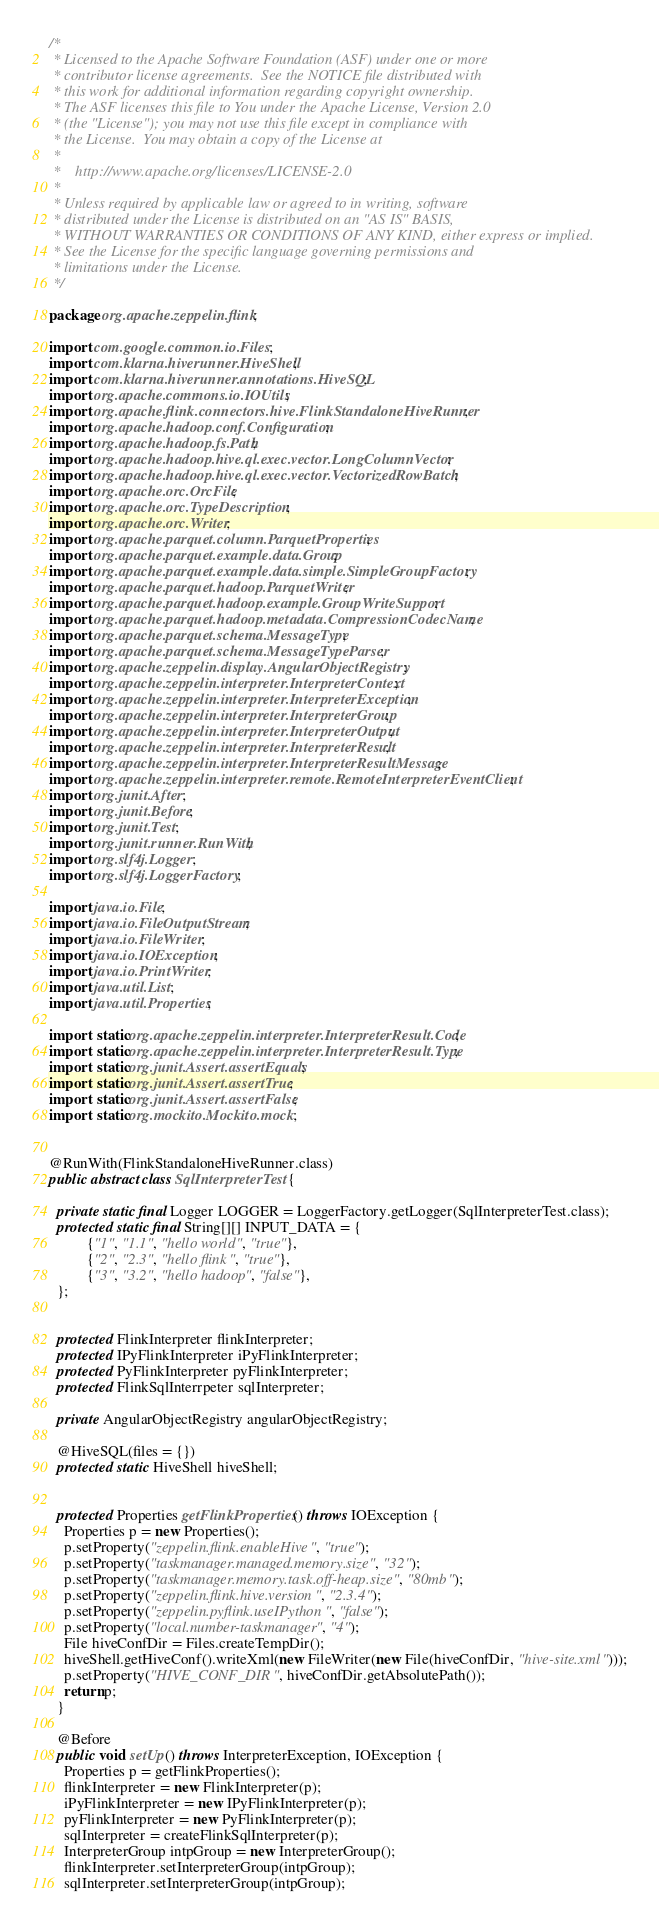<code> <loc_0><loc_0><loc_500><loc_500><_Java_>/*
 * Licensed to the Apache Software Foundation (ASF) under one or more
 * contributor license agreements.  See the NOTICE file distributed with
 * this work for additional information regarding copyright ownership.
 * The ASF licenses this file to You under the Apache License, Version 2.0
 * (the "License"); you may not use this file except in compliance with
 * the License.  You may obtain a copy of the License at
 *
 *    http://www.apache.org/licenses/LICENSE-2.0
 *
 * Unless required by applicable law or agreed to in writing, software
 * distributed under the License is distributed on an "AS IS" BASIS,
 * WITHOUT WARRANTIES OR CONDITIONS OF ANY KIND, either express or implied.
 * See the License for the specific language governing permissions and
 * limitations under the License.
 */

package org.apache.zeppelin.flink;

import com.google.common.io.Files;
import com.klarna.hiverunner.HiveShell;
import com.klarna.hiverunner.annotations.HiveSQL;
import org.apache.commons.io.IOUtils;
import org.apache.flink.connectors.hive.FlinkStandaloneHiveRunner;
import org.apache.hadoop.conf.Configuration;
import org.apache.hadoop.fs.Path;
import org.apache.hadoop.hive.ql.exec.vector.LongColumnVector;
import org.apache.hadoop.hive.ql.exec.vector.VectorizedRowBatch;
import org.apache.orc.OrcFile;
import org.apache.orc.TypeDescription;
import org.apache.orc.Writer;
import org.apache.parquet.column.ParquetProperties;
import org.apache.parquet.example.data.Group;
import org.apache.parquet.example.data.simple.SimpleGroupFactory;
import org.apache.parquet.hadoop.ParquetWriter;
import org.apache.parquet.hadoop.example.GroupWriteSupport;
import org.apache.parquet.hadoop.metadata.CompressionCodecName;
import org.apache.parquet.schema.MessageType;
import org.apache.parquet.schema.MessageTypeParser;
import org.apache.zeppelin.display.AngularObjectRegistry;
import org.apache.zeppelin.interpreter.InterpreterContext;
import org.apache.zeppelin.interpreter.InterpreterException;
import org.apache.zeppelin.interpreter.InterpreterGroup;
import org.apache.zeppelin.interpreter.InterpreterOutput;
import org.apache.zeppelin.interpreter.InterpreterResult;
import org.apache.zeppelin.interpreter.InterpreterResultMessage;
import org.apache.zeppelin.interpreter.remote.RemoteInterpreterEventClient;
import org.junit.After;
import org.junit.Before;
import org.junit.Test;
import org.junit.runner.RunWith;
import org.slf4j.Logger;
import org.slf4j.LoggerFactory;

import java.io.File;
import java.io.FileOutputStream;
import java.io.FileWriter;
import java.io.IOException;
import java.io.PrintWriter;
import java.util.List;
import java.util.Properties;

import static org.apache.zeppelin.interpreter.InterpreterResult.Code;
import static org.apache.zeppelin.interpreter.InterpreterResult.Type;
import static org.junit.Assert.assertEquals;
import static org.junit.Assert.assertTrue;
import static org.junit.Assert.assertFalse;
import static org.mockito.Mockito.mock;


@RunWith(FlinkStandaloneHiveRunner.class)
public abstract class SqlInterpreterTest {

  private static final Logger LOGGER = LoggerFactory.getLogger(SqlInterpreterTest.class);
  protected static final String[][] INPUT_DATA = {
          {"1", "1.1", "hello world", "true"},
          {"2", "2.3", "hello flink", "true"},
          {"3", "3.2", "hello hadoop", "false"},
  };


  protected FlinkInterpreter flinkInterpreter;
  protected IPyFlinkInterpreter iPyFlinkInterpreter;
  protected PyFlinkInterpreter pyFlinkInterpreter;
  protected FlinkSqlInterrpeter sqlInterpreter;

  private AngularObjectRegistry angularObjectRegistry;

  @HiveSQL(files = {})
  protected static HiveShell hiveShell;


  protected Properties getFlinkProperties() throws IOException {
    Properties p = new Properties();
    p.setProperty("zeppelin.flink.enableHive", "true");
    p.setProperty("taskmanager.managed.memory.size", "32");
    p.setProperty("taskmanager.memory.task.off-heap.size", "80mb");
    p.setProperty("zeppelin.flink.hive.version", "2.3.4");
    p.setProperty("zeppelin.pyflink.useIPython", "false");
    p.setProperty("local.number-taskmanager", "4");
    File hiveConfDir = Files.createTempDir();
    hiveShell.getHiveConf().writeXml(new FileWriter(new File(hiveConfDir, "hive-site.xml")));
    p.setProperty("HIVE_CONF_DIR", hiveConfDir.getAbsolutePath());
    return p;
  }

  @Before
  public void setUp() throws InterpreterException, IOException {
    Properties p = getFlinkProperties();
    flinkInterpreter = new FlinkInterpreter(p);
    iPyFlinkInterpreter = new IPyFlinkInterpreter(p);
    pyFlinkInterpreter = new PyFlinkInterpreter(p);
    sqlInterpreter = createFlinkSqlInterpreter(p);
    InterpreterGroup intpGroup = new InterpreterGroup();
    flinkInterpreter.setInterpreterGroup(intpGroup);
    sqlInterpreter.setInterpreterGroup(intpGroup);</code> 